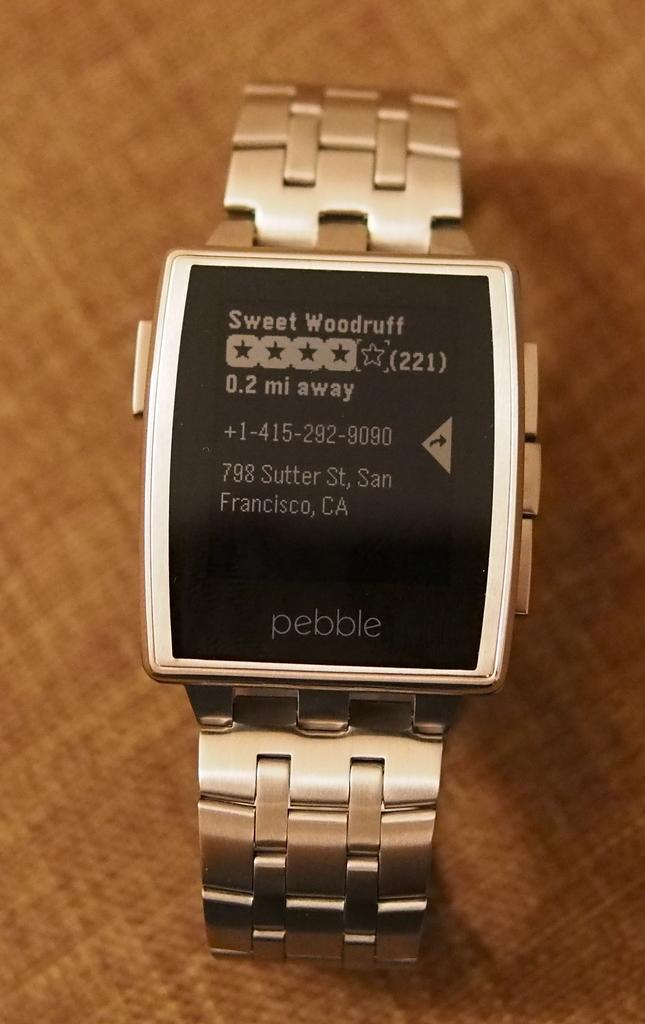Provide a one-sentence caption for the provided image. A Pebble watch display says Sweet Woodruff on it. 